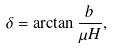Convert formula to latex. <formula><loc_0><loc_0><loc_500><loc_500>\delta = \arctan \frac { b } { \mu H } ,</formula> 